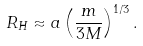Convert formula to latex. <formula><loc_0><loc_0><loc_500><loc_500>R _ { H } \approx a \left ( \frac { m } { 3 M } \right ) ^ { 1 / 3 } .</formula> 